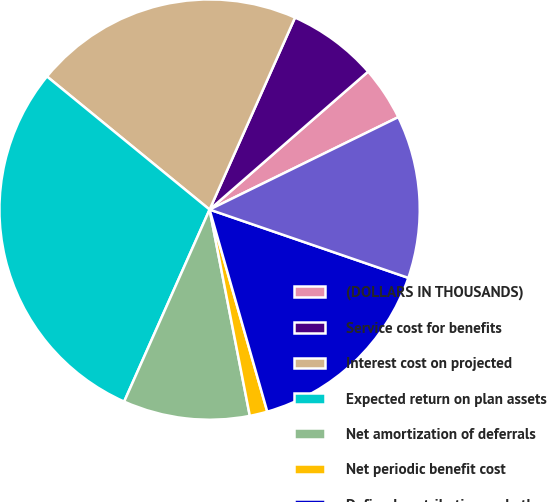<chart> <loc_0><loc_0><loc_500><loc_500><pie_chart><fcel>(DOLLARS IN THOUSANDS)<fcel>Service cost for benefits<fcel>Interest cost on projected<fcel>Expected return on plan assets<fcel>Net amortization of deferrals<fcel>Net periodic benefit cost<fcel>Defined contribution and other<fcel>Total expense<nl><fcel>4.15%<fcel>6.94%<fcel>20.75%<fcel>29.26%<fcel>9.73%<fcel>1.36%<fcel>15.31%<fcel>12.52%<nl></chart> 